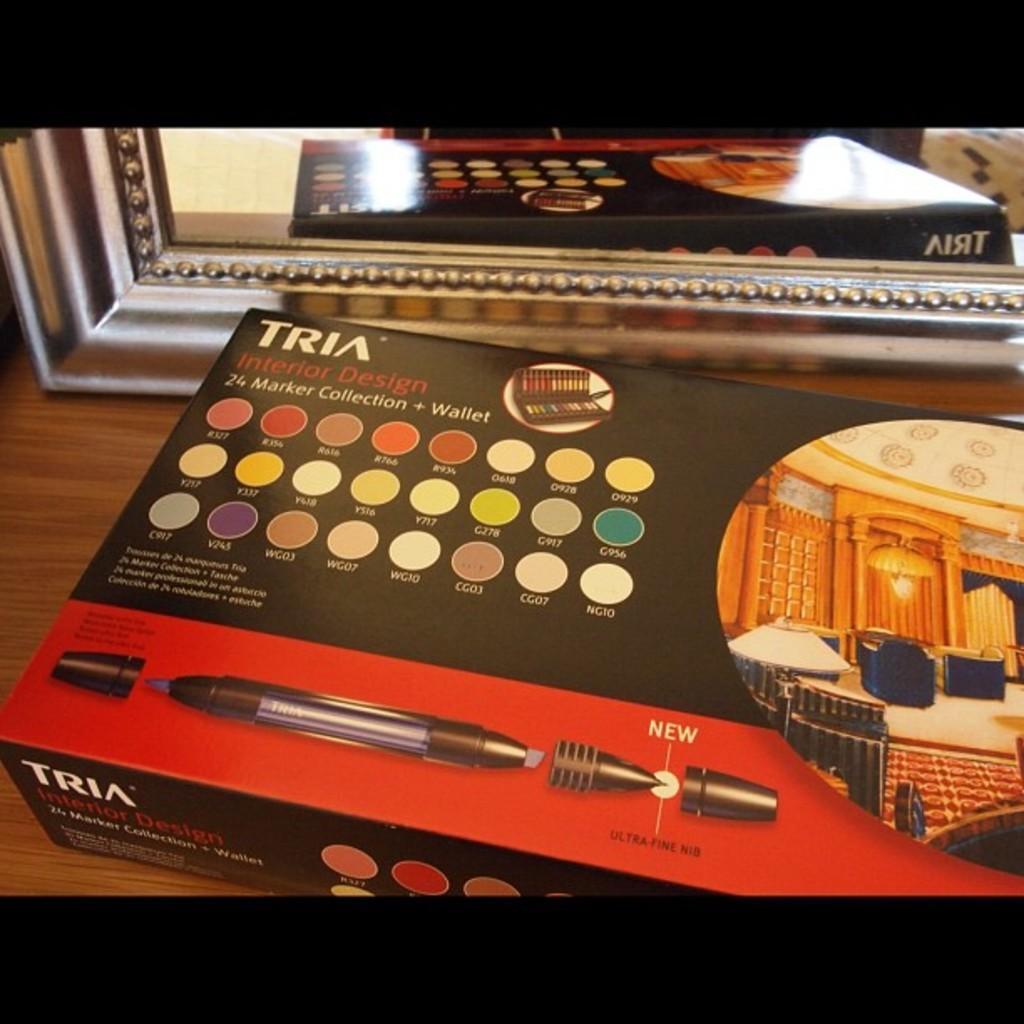What is the brand?
Provide a succinct answer. Tria. 